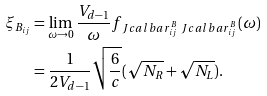<formula> <loc_0><loc_0><loc_500><loc_500>\xi _ { B _ { i j } } & = \lim _ { \omega \to 0 } \frac { V _ { d - 1 } } { \omega } f _ { \ J c a l b a r ^ { B } _ { i j } \ J c a l b a r ^ { B } _ { i j } } ( \omega ) \\ & = \frac { 1 } { 2 V _ { d - 1 } } \sqrt { \frac { 6 } { c } } ( \sqrt { N _ { R } } + \sqrt { N _ { L } } ) .</formula> 